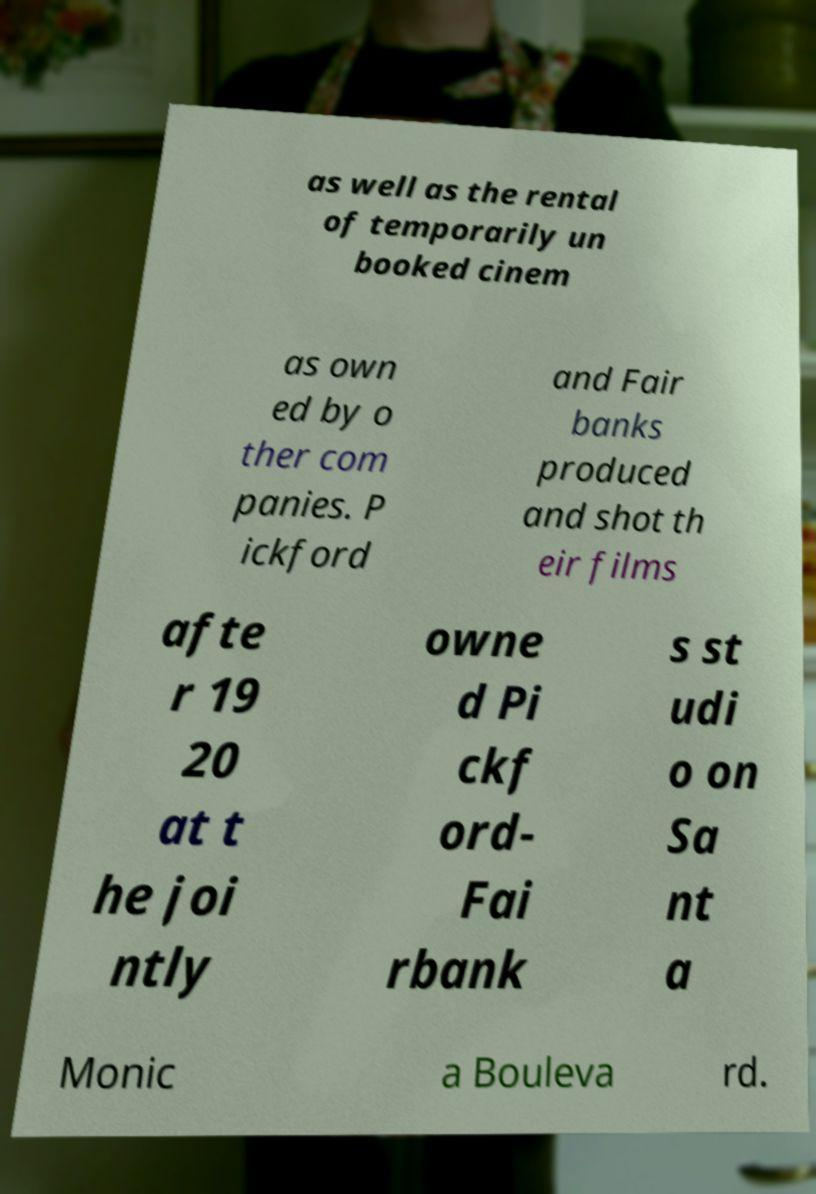Can you read and provide the text displayed in the image?This photo seems to have some interesting text. Can you extract and type it out for me? as well as the rental of temporarily un booked cinem as own ed by o ther com panies. P ickford and Fair banks produced and shot th eir films afte r 19 20 at t he joi ntly owne d Pi ckf ord- Fai rbank s st udi o on Sa nt a Monic a Bouleva rd. 